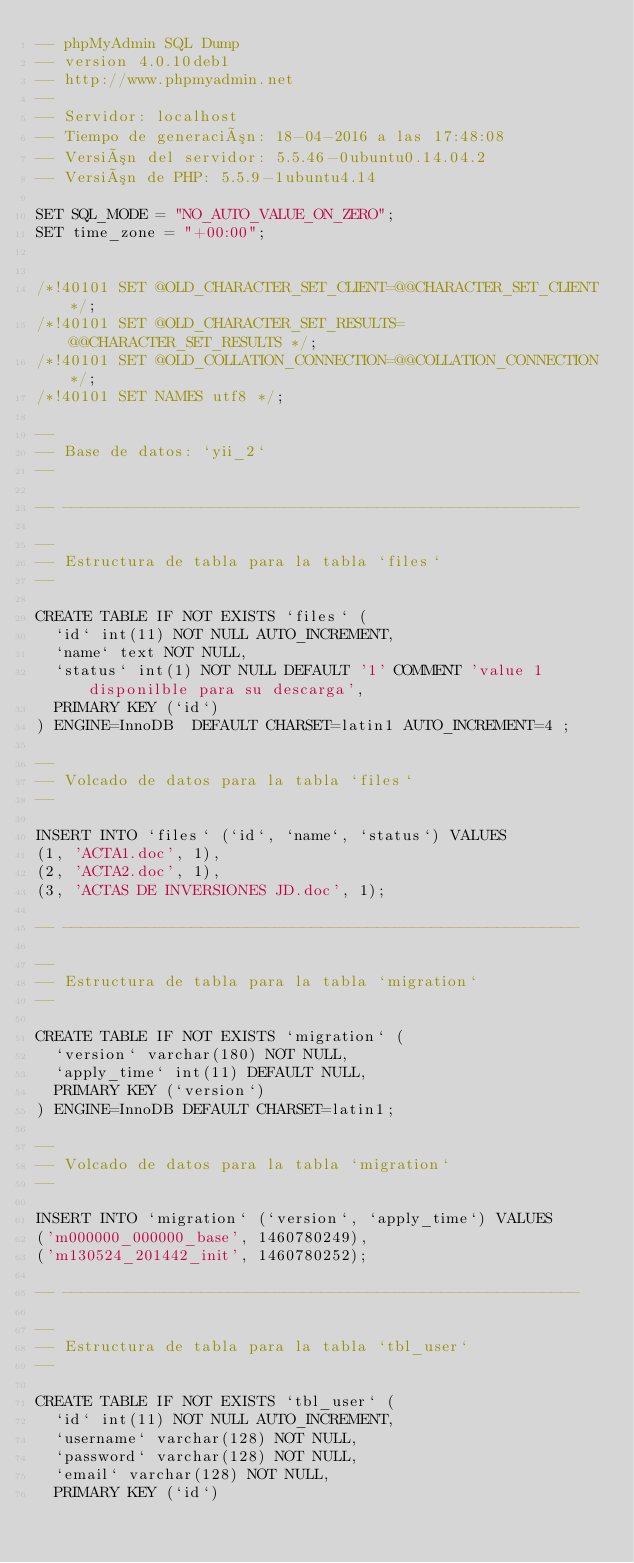<code> <loc_0><loc_0><loc_500><loc_500><_SQL_>-- phpMyAdmin SQL Dump
-- version 4.0.10deb1
-- http://www.phpmyadmin.net
--
-- Servidor: localhost
-- Tiempo de generación: 18-04-2016 a las 17:48:08
-- Versión del servidor: 5.5.46-0ubuntu0.14.04.2
-- Versión de PHP: 5.5.9-1ubuntu4.14

SET SQL_MODE = "NO_AUTO_VALUE_ON_ZERO";
SET time_zone = "+00:00";


/*!40101 SET @OLD_CHARACTER_SET_CLIENT=@@CHARACTER_SET_CLIENT */;
/*!40101 SET @OLD_CHARACTER_SET_RESULTS=@@CHARACTER_SET_RESULTS */;
/*!40101 SET @OLD_COLLATION_CONNECTION=@@COLLATION_CONNECTION */;
/*!40101 SET NAMES utf8 */;

--
-- Base de datos: `yii_2`
--

-- --------------------------------------------------------

--
-- Estructura de tabla para la tabla `files`
--

CREATE TABLE IF NOT EXISTS `files` (
  `id` int(11) NOT NULL AUTO_INCREMENT,
  `name` text NOT NULL,
  `status` int(1) NOT NULL DEFAULT '1' COMMENT 'value 1 disponilble para su descarga',
  PRIMARY KEY (`id`)
) ENGINE=InnoDB  DEFAULT CHARSET=latin1 AUTO_INCREMENT=4 ;

--
-- Volcado de datos para la tabla `files`
--

INSERT INTO `files` (`id`, `name`, `status`) VALUES
(1, 'ACTA1.doc', 1),
(2, 'ACTA2.doc', 1),
(3, 'ACTAS DE INVERSIONES JD.doc', 1);

-- --------------------------------------------------------

--
-- Estructura de tabla para la tabla `migration`
--

CREATE TABLE IF NOT EXISTS `migration` (
  `version` varchar(180) NOT NULL,
  `apply_time` int(11) DEFAULT NULL,
  PRIMARY KEY (`version`)
) ENGINE=InnoDB DEFAULT CHARSET=latin1;

--
-- Volcado de datos para la tabla `migration`
--

INSERT INTO `migration` (`version`, `apply_time`) VALUES
('m000000_000000_base', 1460780249),
('m130524_201442_init', 1460780252);

-- --------------------------------------------------------

--
-- Estructura de tabla para la tabla `tbl_user`
--

CREATE TABLE IF NOT EXISTS `tbl_user` (
  `id` int(11) NOT NULL AUTO_INCREMENT,
  `username` varchar(128) NOT NULL,
  `password` varchar(128) NOT NULL,
  `email` varchar(128) NOT NULL,
  PRIMARY KEY (`id`)</code> 